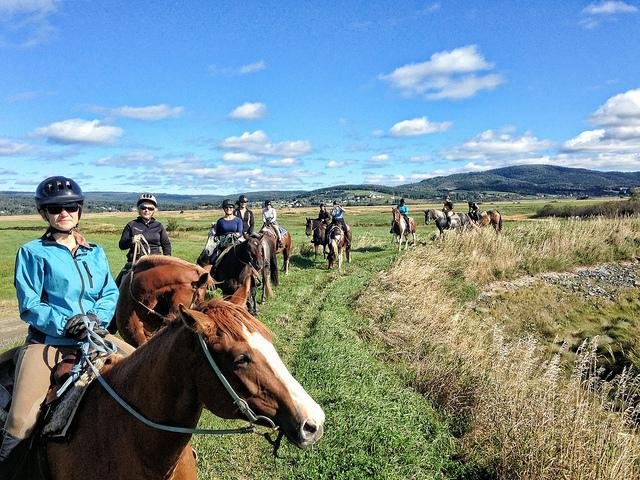What do these horseback riders ride along? trail 